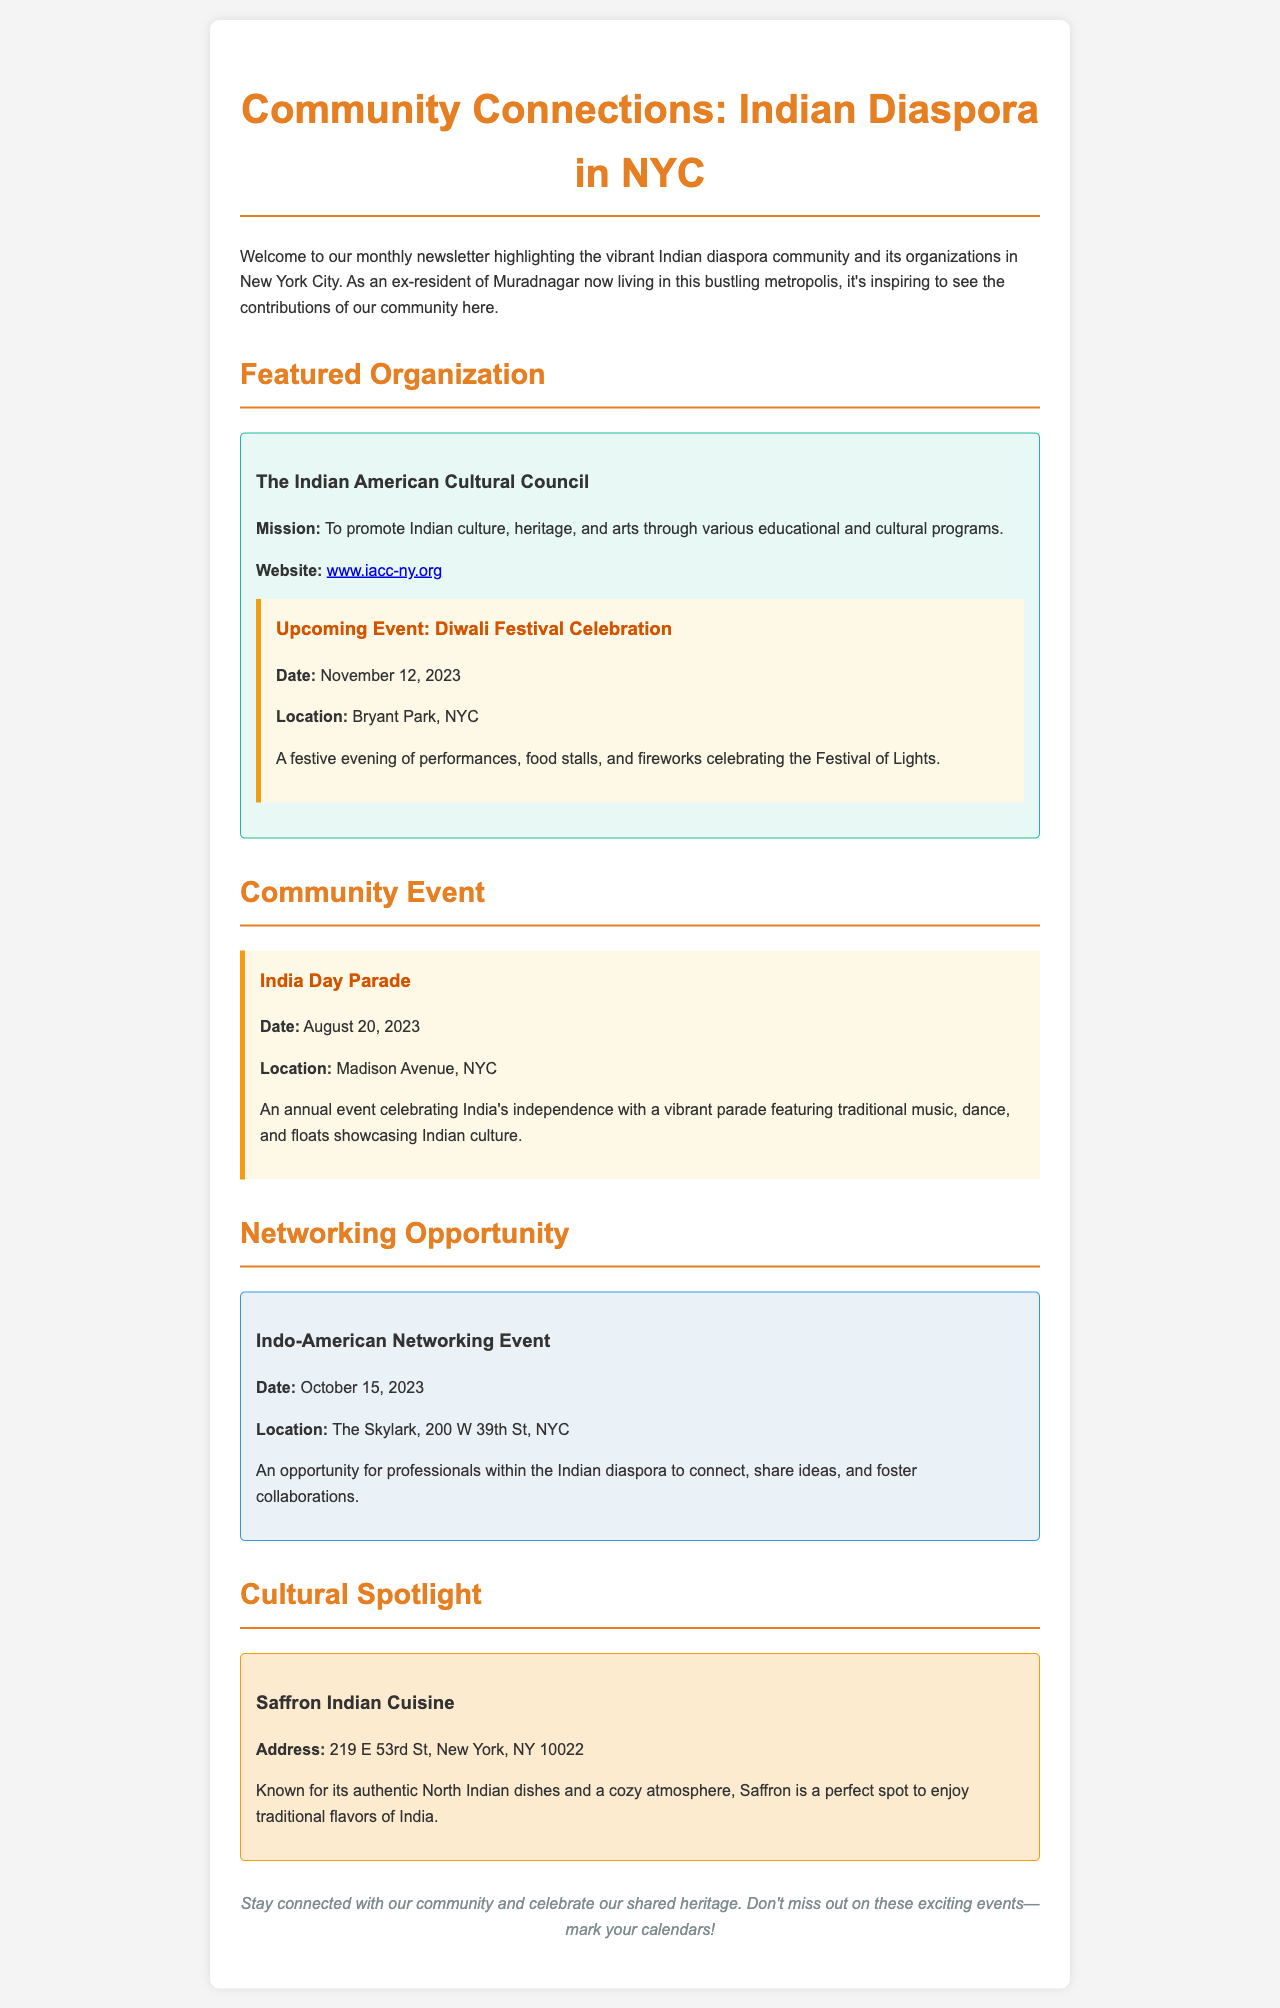what is the name of the featured organization? The featured organization is mentioned in the section titled "Featured Organization."
Answer: The Indian American Cultural Council when is the Diwali Festival Celebration? The date for the Diwali Festival Celebration is provided in the "Upcoming Event" section of the organization.
Answer: November 12, 2023 where is the India Day Parade located? The location for the India Day Parade is specified under the "Community Event" section.
Answer: Madison Avenue, NYC what type of cuisine does Saffron Indian Cuisine offer? The type of cuisine offered by Saffron is indicated in the "Cultural Spotlight" section.
Answer: North Indian dishes what is the purpose of the Indo-American Networking Event? The purpose of the Indo-American Networking Event is described in the "Networking Opportunity" section.
Answer: Connect, share ideas, and foster collaborations how many community events are highlighted in the document? The number of community events can be counted from the sections under "Community Event," "Networking Opportunity," and the section title "Featured Organization."
Answer: Three 